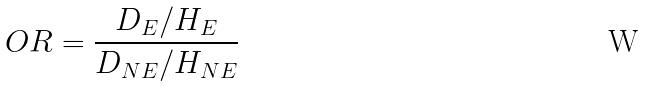<formula> <loc_0><loc_0><loc_500><loc_500>O R = \frac { D _ { E } / H _ { E } } { D _ { N E } / H _ { N E } }</formula> 